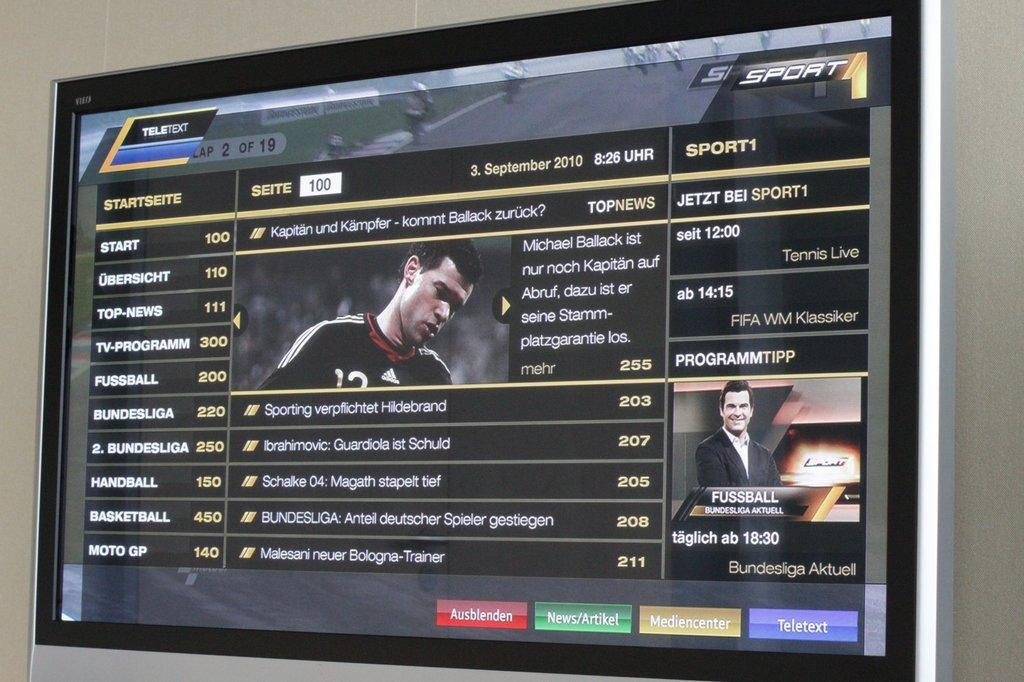What electronic device is present in the image? There is a television in the image. What is the primary feature of the television? The television has a screen. What can be seen on the screen of the television? There are two people on the screen of the television. What type of scent is being emitted by the lizards in the image? There are no lizards present in the image, so it is not possible to determine what scent they might be emitting. 